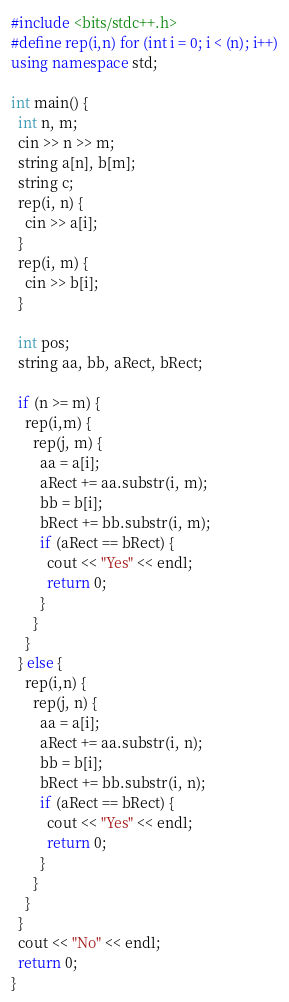<code> <loc_0><loc_0><loc_500><loc_500><_C++_>#include <bits/stdc++.h>
#define rep(i,n) for (int i = 0; i < (n); i++)
using namespace std;

int main() {
  int n, m;
  cin >> n >> m;
  string a[n], b[m];
  string c;
  rep(i, n) {
    cin >> a[i]; 
  }
  rep(i, m) {
    cin >> b[i];
  }
  
  int pos;
  string aa, bb, aRect, bRect;
   
  if (n >= m) {
    rep(i,m) {
      rep(j, m) {
        aa = a[i];
        aRect += aa.substr(i, m);
        bb = b[i];
        bRect += bb.substr(i, m);
        if (aRect == bRect) {
          cout << "Yes" << endl;
          return 0;
        }
      }
    }
  } else {
    rep(i,n) {
      rep(j, n) {
        aa = a[i];
        aRect += aa.substr(i, n);
        bb = b[i];
        bRect += bb.substr(i, n);
        if (aRect == bRect) {
          cout << "Yes" << endl;
          return 0;
        }
      }
    }
  }
  cout << "No" << endl;
  return 0;
}</code> 